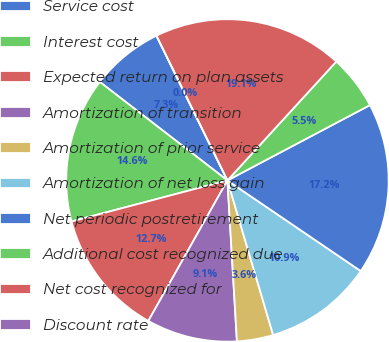<chart> <loc_0><loc_0><loc_500><loc_500><pie_chart><fcel>Service cost<fcel>Interest cost<fcel>Expected return on plan assets<fcel>Amortization of transition<fcel>Amortization of prior service<fcel>Amortization of net loss gain<fcel>Net periodic postretirement<fcel>Additional cost recognized due<fcel>Net cost recognized for<fcel>Discount rate<nl><fcel>7.28%<fcel>14.56%<fcel>12.74%<fcel>9.1%<fcel>3.64%<fcel>10.92%<fcel>17.24%<fcel>5.46%<fcel>19.06%<fcel>0.0%<nl></chart> 